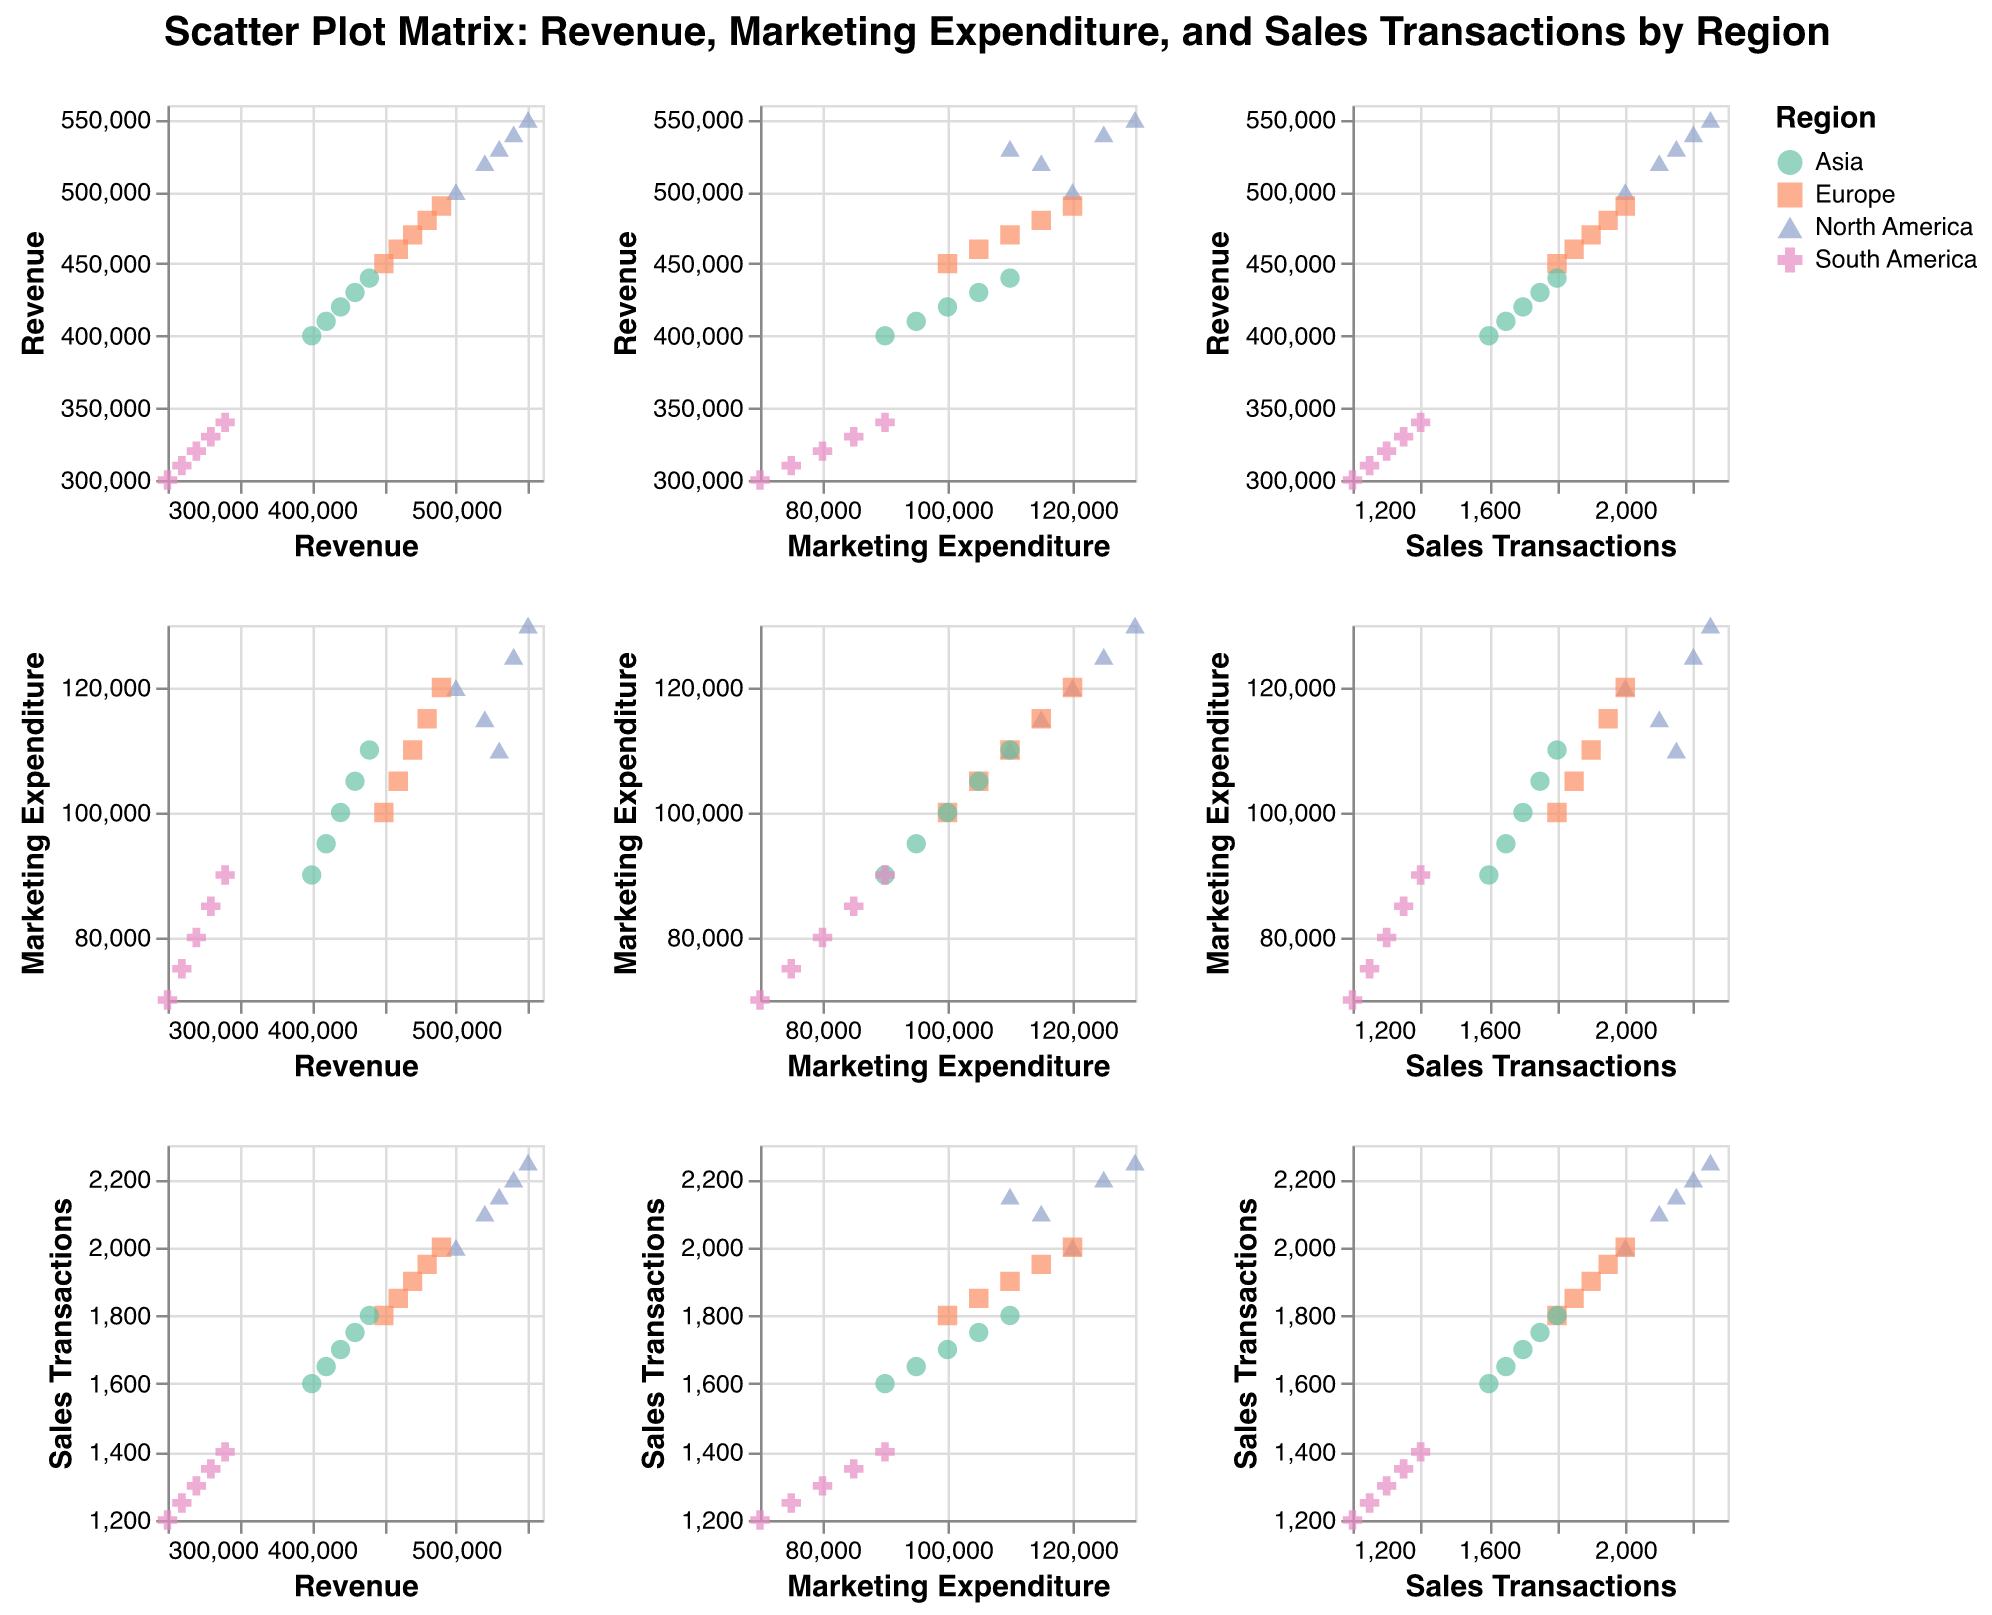What is the title of the figure? The title of the figure is displayed prominently at the top and describes what is being shown.
Answer: Scatter Plot Matrix: Revenue, Marketing Expenditure, and Sales Transactions by Region How many regions are represented by different colors in the plot? In the legend, there are four distinct colors, each representing a different region.
Answer: Four Which region has the highest revenue in the month of May? By looking at the region represented by the color with the highest revenue value in May, you can identify this.
Answer: North America Compare the marketing expenditure in April for Europe and Asia. Which region had higher expenditure? By locating the data points for April in Europe and Asia and comparing their positions on the marketing expenditure axis, one can determine this.
Answer: Europe Is there a noticeable trend between revenue and marketing expenditure in any specific region? Each region's scatter plot can be examined to see if an increase in marketing expenditure correlates with an increase in revenue.
Answer: Generally, yes, marketing expenditure and revenue tend to increase together for most regions What is the range of sales transactions for North America? Identify the minimum and maximum values of sales transactions for North America by reviewing the scatter plots.
Answer: 2000-2250 Which region shows the least variation in marketing expenditure over the months? By observing the spread of points in the marketing expenditure axis for each region, the region with the tightest clustering values has the least variation.
Answer: Asia Does higher marketing expenditure always correlate with higher revenue in this data set? By inspecting the scatter plot of revenue against marketing expenditure across all regions, one can identify any deviations from this trend.
Answer: No, while they generally increase together, it is not an absolute correlation For the month of April, which region has the highest number of sales transactions? By looking at the data points for April and examining their positions on the sales transactions axis, the highest value can be identified.
Answer: North America What is the average revenue for South America over the observed months? Calculate the average by summing all the revenue figures for South America and dividing by the number of months (January to May). (300,000 + 310,000 + 320,000 + 330,000 + 340,000) / 5 = 320,000.
Answer: 320,000 